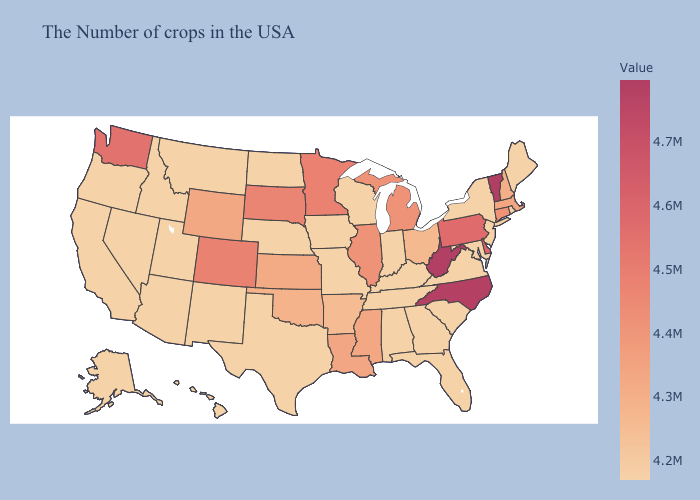Which states have the lowest value in the USA?
Write a very short answer. Maine, Rhode Island, New York, New Jersey, Maryland, Virginia, South Carolina, Florida, Georgia, Kentucky, Indiana, Alabama, Tennessee, Wisconsin, Missouri, Iowa, Nebraska, Texas, North Dakota, New Mexico, Utah, Montana, Arizona, Idaho, Nevada, California, Oregon, Alaska, Hawaii. Does the map have missing data?
Quick response, please. No. Which states hav the highest value in the South?
Keep it brief. West Virginia. Which states hav the highest value in the West?
Give a very brief answer. Washington. Among the states that border Wyoming , which have the highest value?
Quick response, please. Colorado. Which states have the lowest value in the USA?
Answer briefly. Maine, Rhode Island, New York, New Jersey, Maryland, Virginia, South Carolina, Florida, Georgia, Kentucky, Indiana, Alabama, Tennessee, Wisconsin, Missouri, Iowa, Nebraska, Texas, North Dakota, New Mexico, Utah, Montana, Arizona, Idaho, Nevada, California, Oregon, Alaska, Hawaii. Which states have the lowest value in the USA?
Give a very brief answer. Maine, Rhode Island, New York, New Jersey, Maryland, Virginia, South Carolina, Florida, Georgia, Kentucky, Indiana, Alabama, Tennessee, Wisconsin, Missouri, Iowa, Nebraska, Texas, North Dakota, New Mexico, Utah, Montana, Arizona, Idaho, Nevada, California, Oregon, Alaska, Hawaii. 